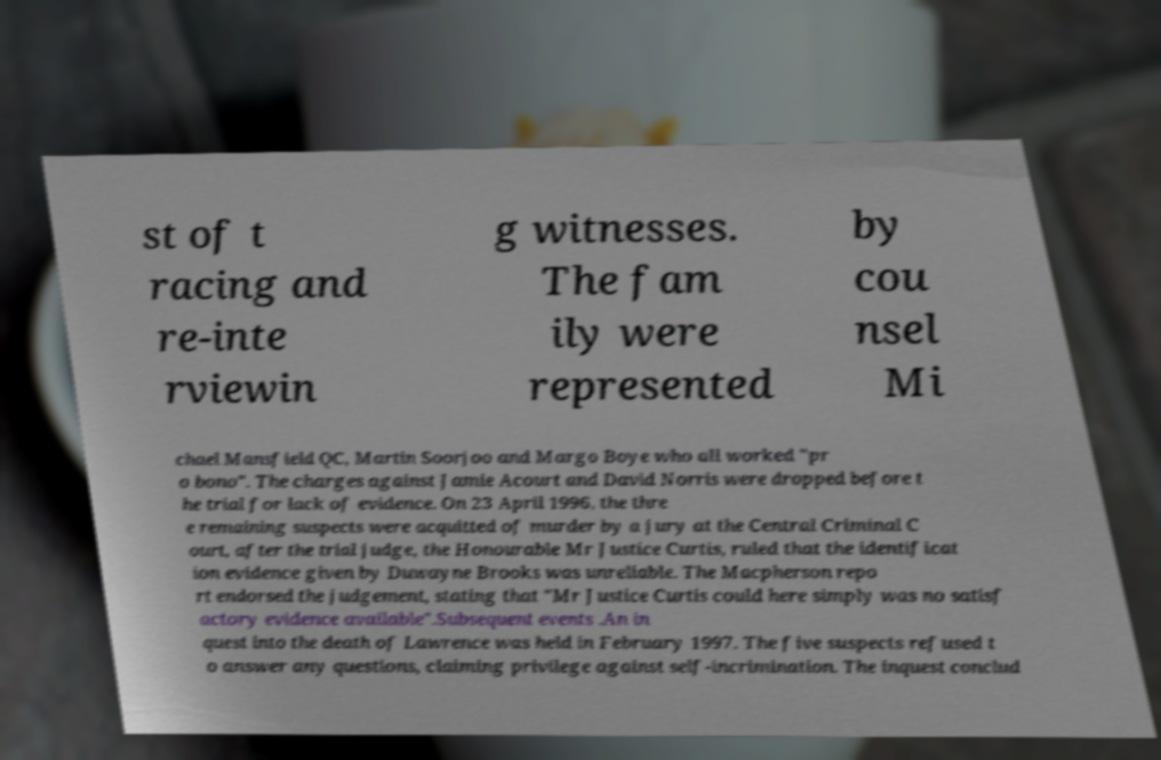Please read and relay the text visible in this image. What does it say? st of t racing and re-inte rviewin g witnesses. The fam ily were represented by cou nsel Mi chael Mansfield QC, Martin Soorjoo and Margo Boye who all worked "pr o bono". The charges against Jamie Acourt and David Norris were dropped before t he trial for lack of evidence. On 23 April 1996, the thre e remaining suspects were acquitted of murder by a jury at the Central Criminal C ourt, after the trial judge, the Honourable Mr Justice Curtis, ruled that the identificat ion evidence given by Duwayne Brooks was unreliable. The Macpherson repo rt endorsed the judgement, stating that "Mr Justice Curtis could here simply was no satisf actory evidence available".Subsequent events .An in quest into the death of Lawrence was held in February 1997. The five suspects refused t o answer any questions, claiming privilege against self-incrimination. The inquest conclud 